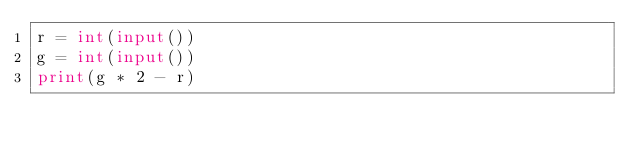Convert code to text. <code><loc_0><loc_0><loc_500><loc_500><_Python_>r = int(input())
g = int(input())
print(g * 2 - r)
</code> 